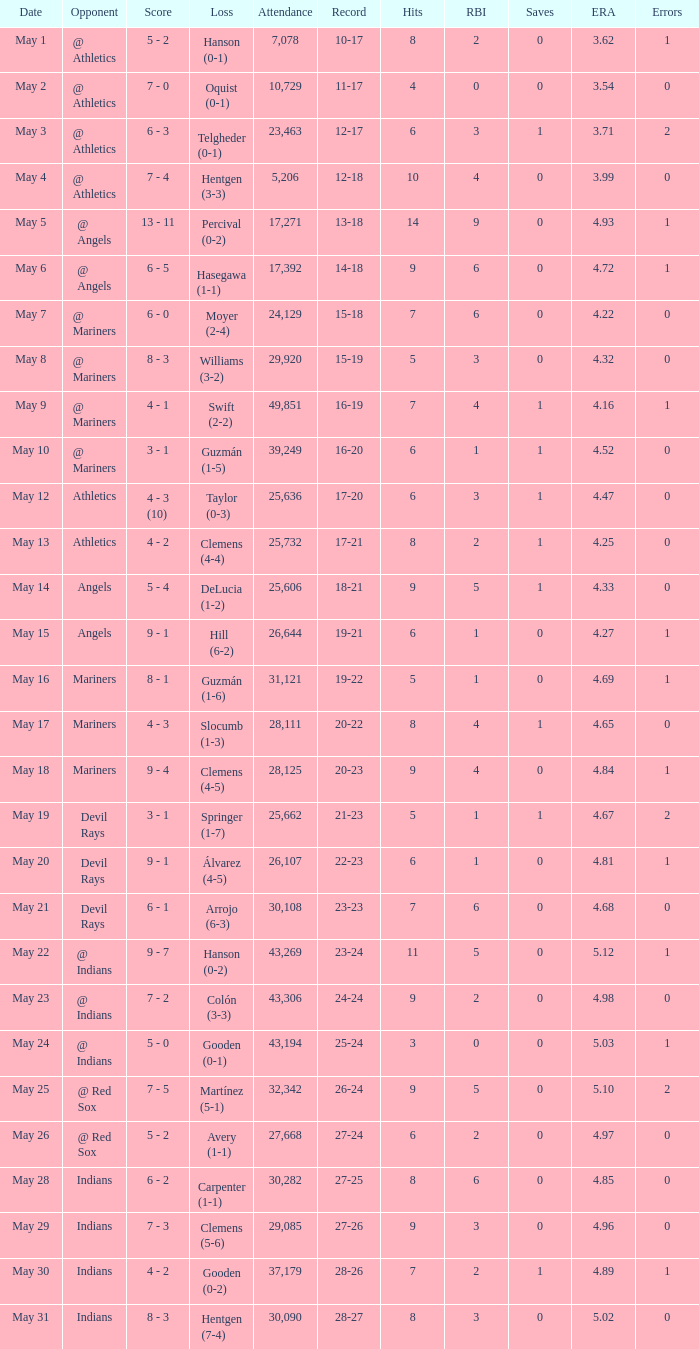For record 25-24, what is the sum of attendance? 1.0. 